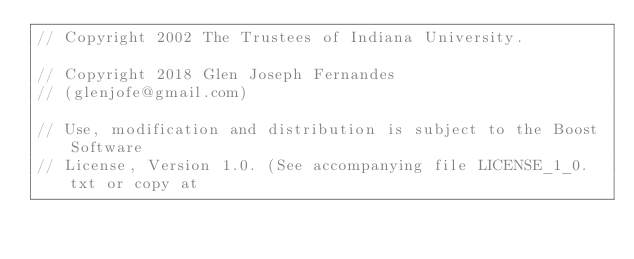<code> <loc_0><loc_0><loc_500><loc_500><_C++_>// Copyright 2002 The Trustees of Indiana University.

// Copyright 2018 Glen Joseph Fernandes
// (glenjofe@gmail.com)

// Use, modification and distribution is subject to the Boost Software 
// License, Version 1.0. (See accompanying file LICENSE_1_0.txt or copy at</code> 